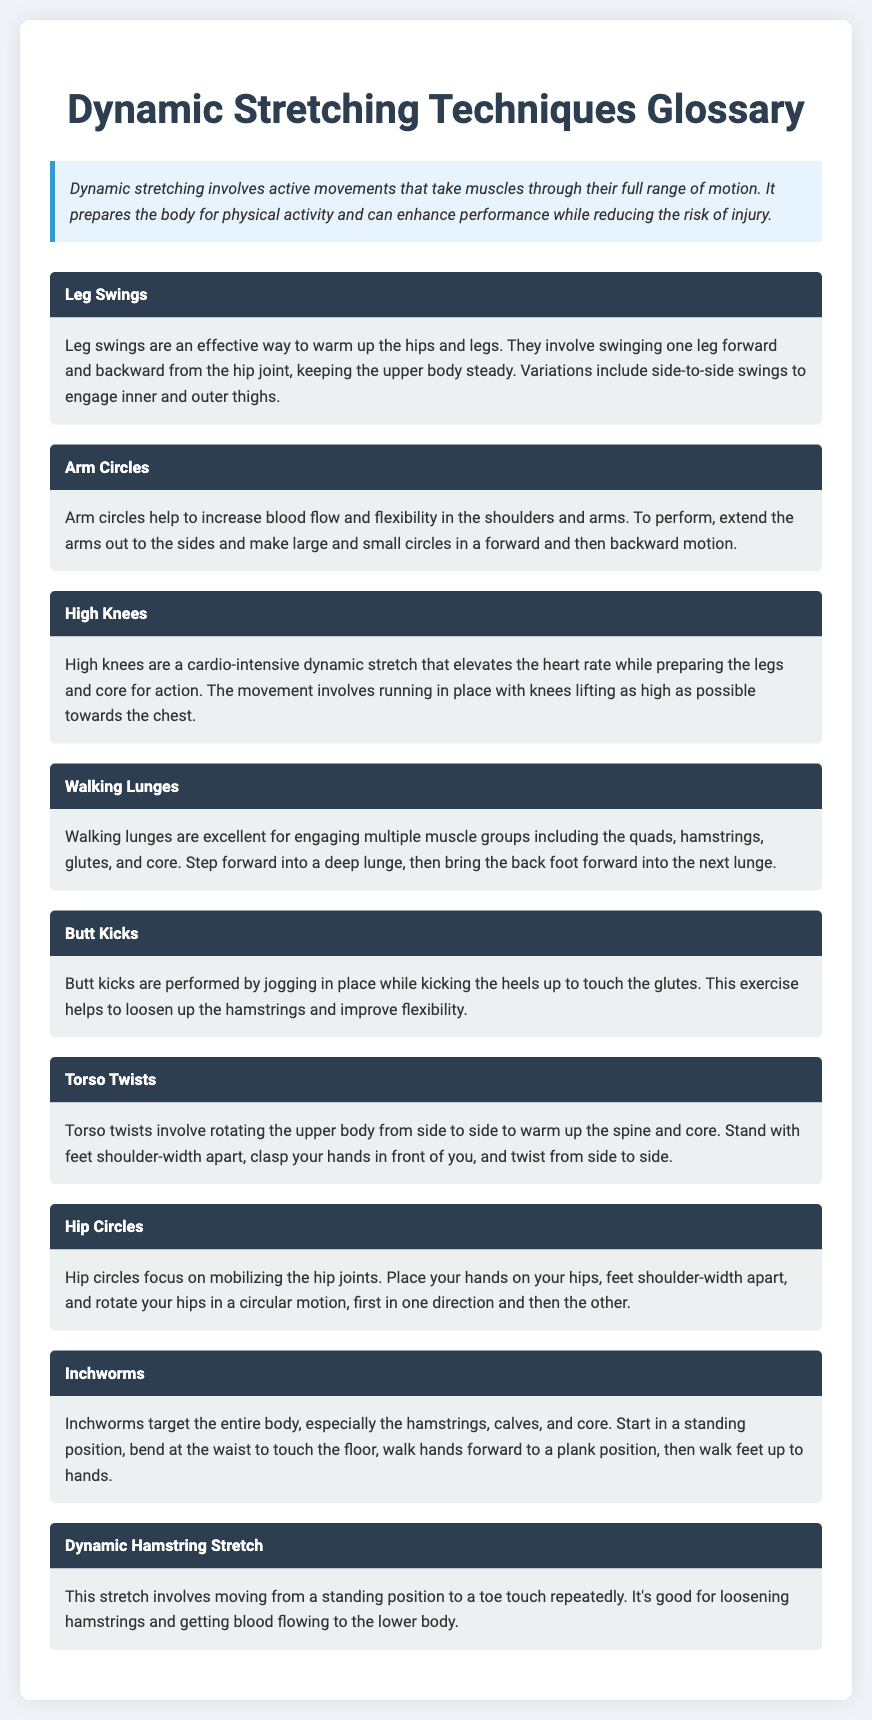what is dynamic stretching? Dynamic stretching involves active movements that take muscles through their full range of motion.
Answer: active movements what is the purpose of leg swings? Leg swings are an effective way to warm up the hips and legs.
Answer: warm up hips and legs what dynamic stretch elevates the heart rate? High knees are a cardio-intensive dynamic stretch that elevates the heart rate.
Answer: High knees which exercise engages the quads, hamstrings, glutes, and core? Walking lunges are excellent for engaging multiple muscle groups including the quads, hamstrings, glutes, and core.
Answer: Walking lunges how are torso twists performed? Torso twists involve rotating the upper body from side to side.
Answer: rotating the upper body what is the starting position for inchworms? Start in a standing position.
Answer: standing position 